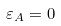Convert formula to latex. <formula><loc_0><loc_0><loc_500><loc_500>\varepsilon _ { A } = 0</formula> 